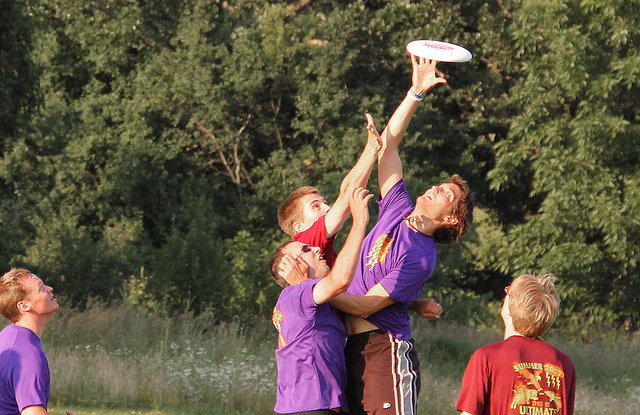Please transcribe the text in this image. ULTIMAT 